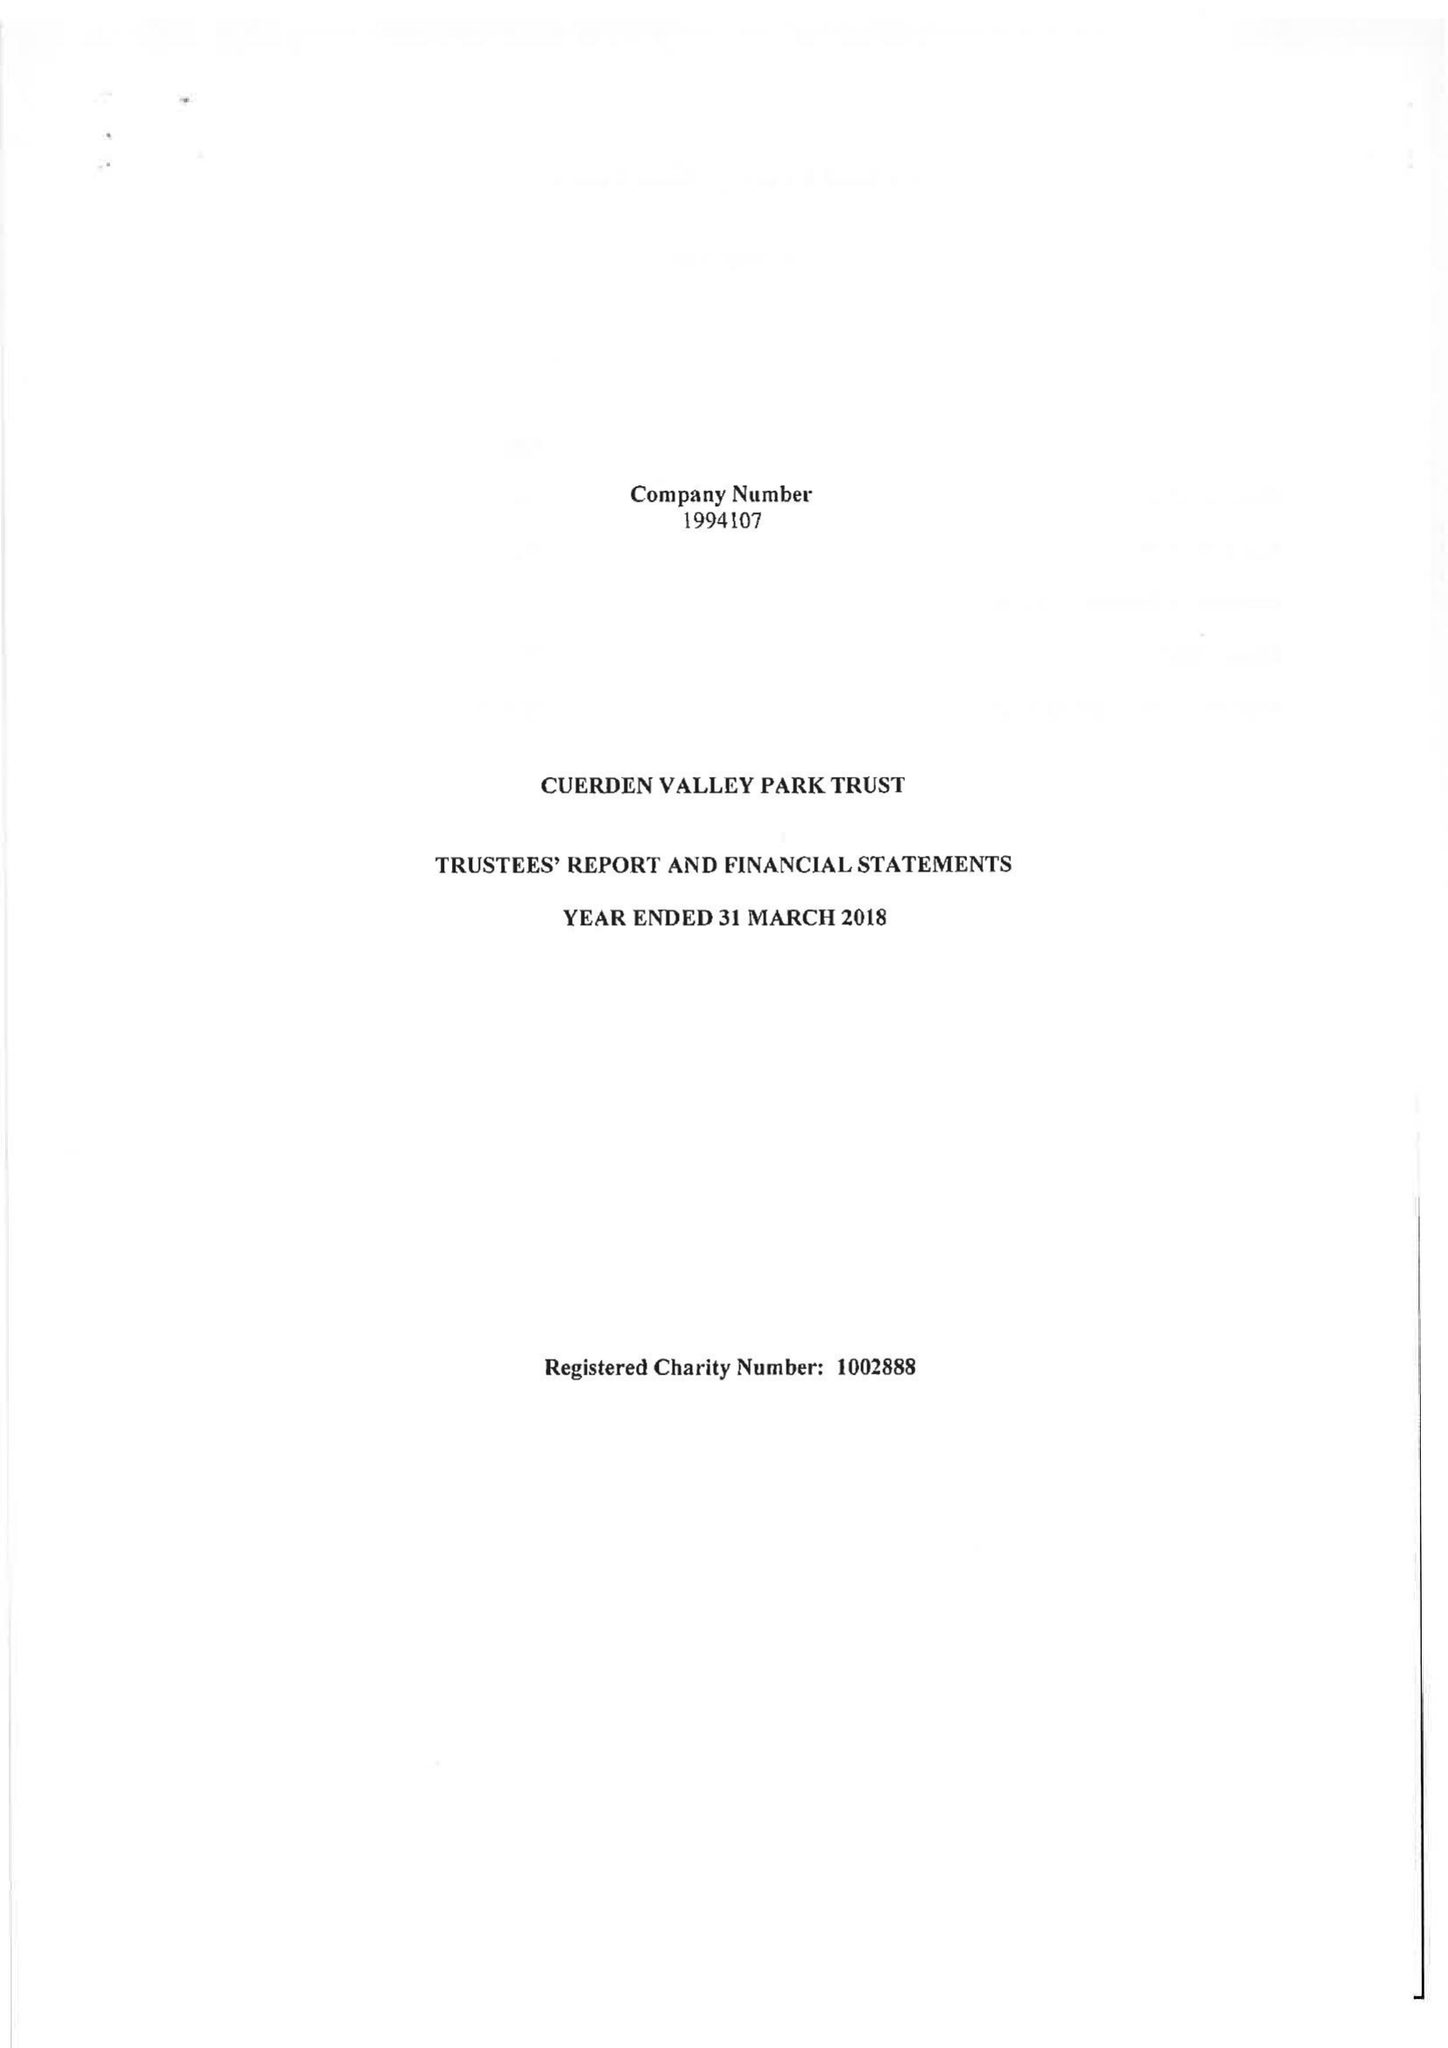What is the value for the report_date?
Answer the question using a single word or phrase. 2018-03-31 